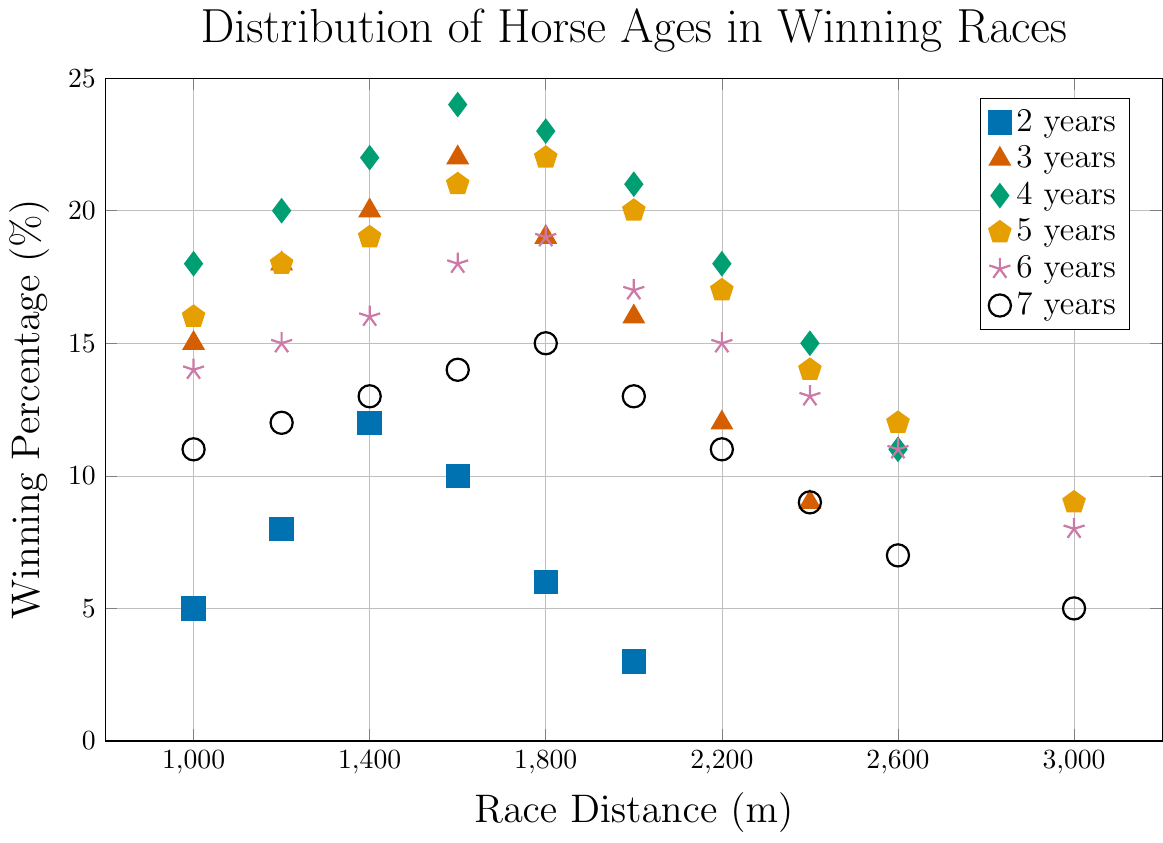What's the winning percentage for 4-year-old horses in 1600m races? Locate the dot representing 4-year-old horses (green diamond) along the 1600m mark on the x-axis. The y-axis value is 24%.
Answer: 24% Which age group has the highest winning percentage in 2000m races? Compare the y-values of the dots along the 2000m mark for all age groups. The 4-year-old group (green diamond) has the highest winning percentage at 21%.
Answer: 4-year-old Do 3-year-old horses perform better in shorter races (1000-1400m) compared to longer races (2000-2400m)? Calculate the average winning percentages for 3-year-old horses in the 1000-1400m range (15, 18, 20: Average = 17.67%) and the 2000-2400m range (16, 12, 9: Average = 12.33%). Compare the averages, noting better performance in shorter races.
Answer: Yes Between 5-year-old and 6-year-old horses, which group has a higher winning percentage in 1800m races? Look at the y-values along the 1800m mark for 5-year-olds (yellow pentagon) and 6-year-olds (purple star). 5-year-olds have 22%, and 6-year-olds have 19%.
Answer: 5-year-old What is the overall trend in winning percentage as race distance increases for 7-year-old horses? Observe the black circles (representing 7-year-olds) from left to right. The winning percentages (11, 12, 13, 14, 15, 13, 11, 9, 7, 5) generally show a decreasing trend with increasing race distance.
Answer: Decreasing 